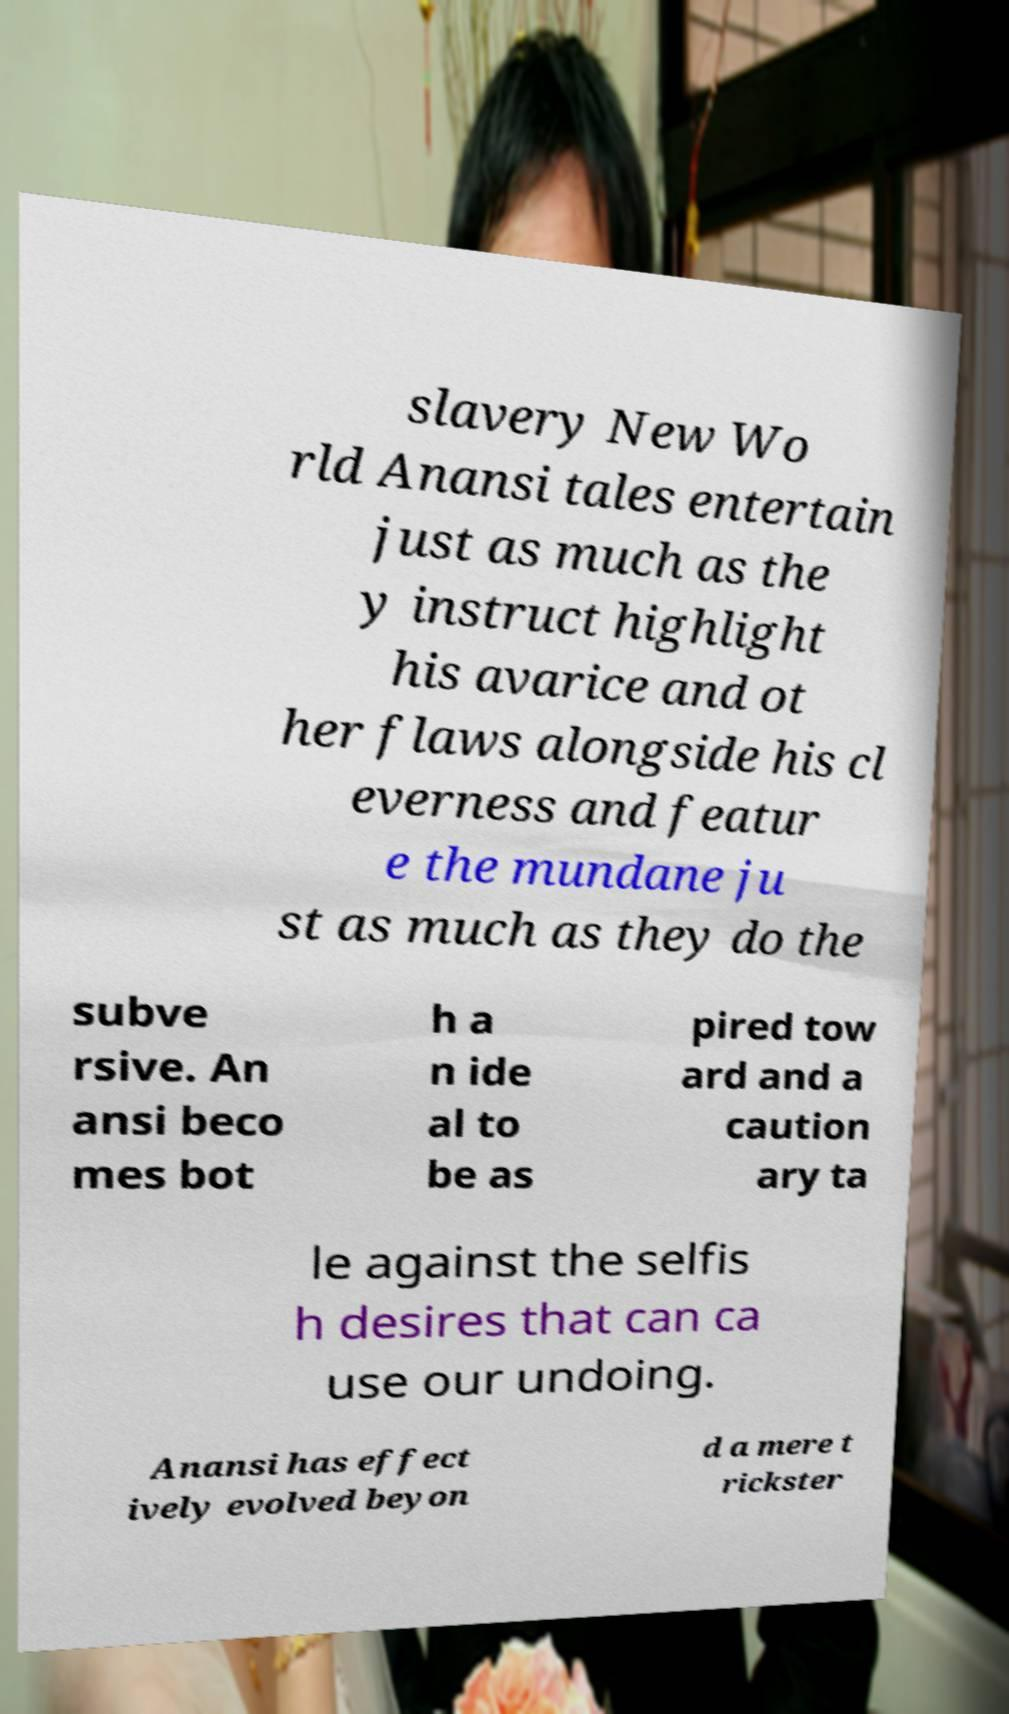What messages or text are displayed in this image? I need them in a readable, typed format. slavery New Wo rld Anansi tales entertain just as much as the y instruct highlight his avarice and ot her flaws alongside his cl everness and featur e the mundane ju st as much as they do the subve rsive. An ansi beco mes bot h a n ide al to be as pired tow ard and a caution ary ta le against the selfis h desires that can ca use our undoing. Anansi has effect ively evolved beyon d a mere t rickster 